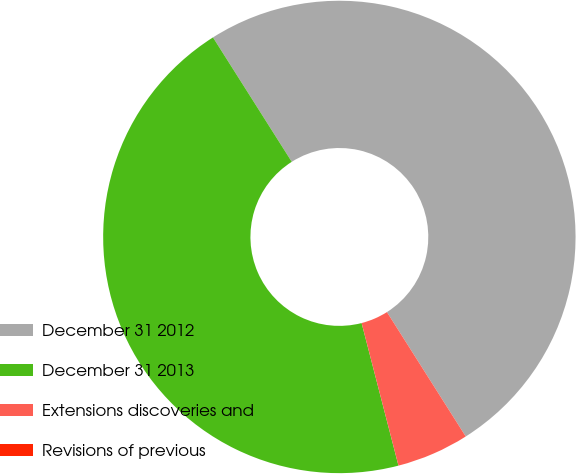Convert chart to OTSL. <chart><loc_0><loc_0><loc_500><loc_500><pie_chart><fcel>December 31 2012<fcel>December 31 2013<fcel>Extensions discoveries and<fcel>Revisions of previous<nl><fcel>50.0%<fcel>45.04%<fcel>4.96%<fcel>0.0%<nl></chart> 